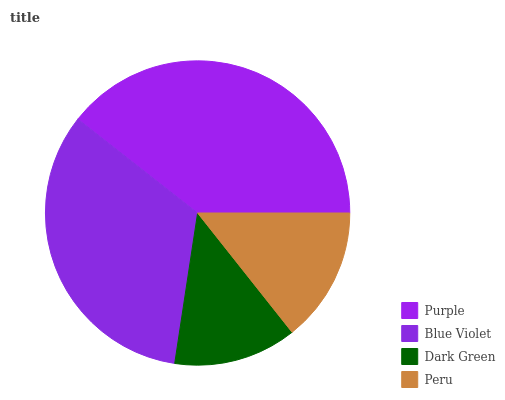Is Dark Green the minimum?
Answer yes or no. Yes. Is Purple the maximum?
Answer yes or no. Yes. Is Blue Violet the minimum?
Answer yes or no. No. Is Blue Violet the maximum?
Answer yes or no. No. Is Purple greater than Blue Violet?
Answer yes or no. Yes. Is Blue Violet less than Purple?
Answer yes or no. Yes. Is Blue Violet greater than Purple?
Answer yes or no. No. Is Purple less than Blue Violet?
Answer yes or no. No. Is Blue Violet the high median?
Answer yes or no. Yes. Is Peru the low median?
Answer yes or no. Yes. Is Peru the high median?
Answer yes or no. No. Is Blue Violet the low median?
Answer yes or no. No. 